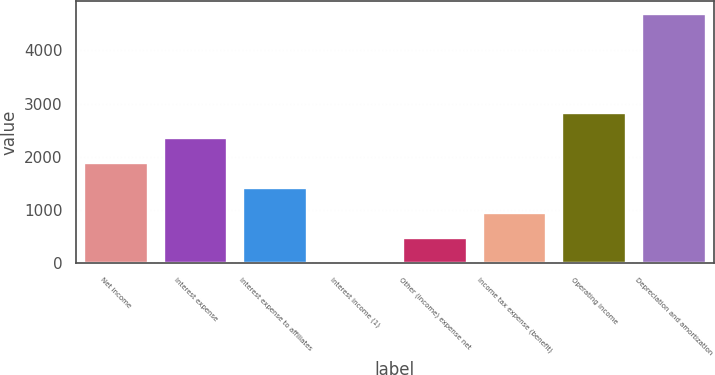Convert chart. <chart><loc_0><loc_0><loc_500><loc_500><bar_chart><fcel>Net income<fcel>Interest expense<fcel>Interest expense to affiliates<fcel>Interest income (1)<fcel>Other (income) expense net<fcel>Income tax expense (benefit)<fcel>Operating income<fcel>Depreciation and amortization<nl><fcel>1878.8<fcel>2347<fcel>1410.6<fcel>6<fcel>474.2<fcel>942.4<fcel>2815.2<fcel>4688<nl></chart> 